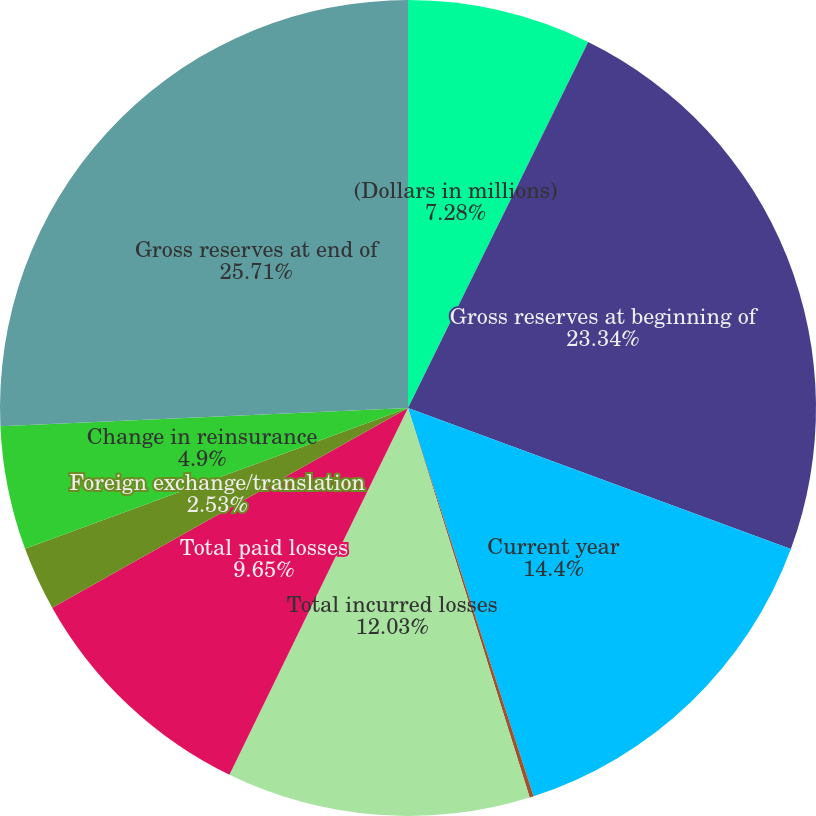Convert chart to OTSL. <chart><loc_0><loc_0><loc_500><loc_500><pie_chart><fcel>(Dollars in millions)<fcel>Gross reserves at beginning of<fcel>Current year<fcel>Prior years<fcel>Total incurred losses<fcel>Total paid losses<fcel>Foreign exchange/translation<fcel>Change in reinsurance<fcel>Gross reserves at end of<nl><fcel>7.28%<fcel>23.34%<fcel>14.4%<fcel>0.16%<fcel>12.03%<fcel>9.65%<fcel>2.53%<fcel>4.9%<fcel>25.71%<nl></chart> 